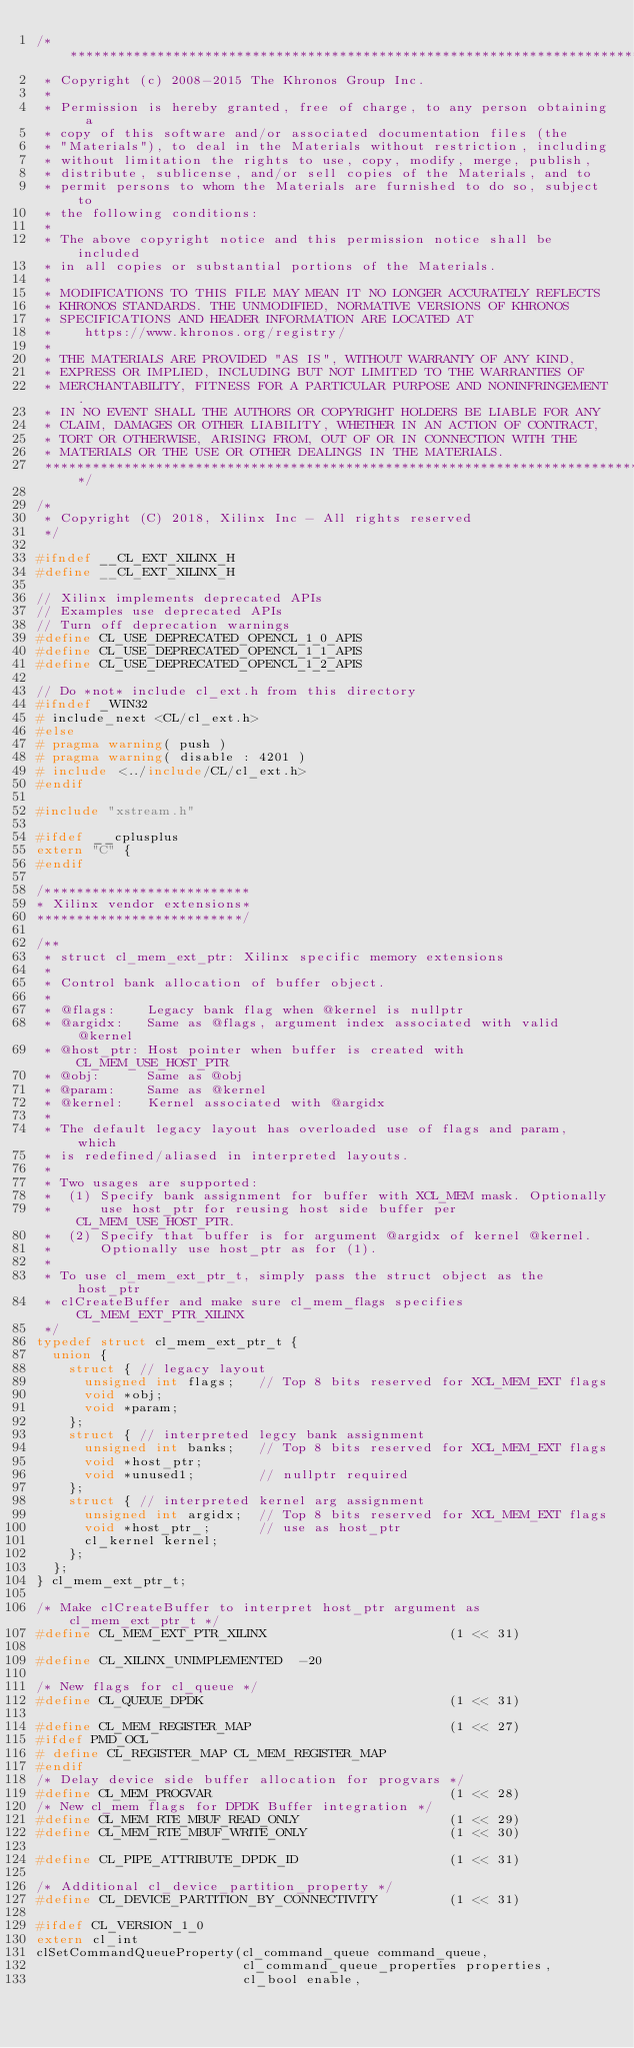Convert code to text. <code><loc_0><loc_0><loc_500><loc_500><_C_>/*******************************************************************************
 * Copyright (c) 2008-2015 The Khronos Group Inc.
 *
 * Permission is hereby granted, free of charge, to any person obtaining a
 * copy of this software and/or associated documentation files (the
 * "Materials"), to deal in the Materials without restriction, including
 * without limitation the rights to use, copy, modify, merge, publish,
 * distribute, sublicense, and/or sell copies of the Materials, and to
 * permit persons to whom the Materials are furnished to do so, subject to
 * the following conditions:
 *
 * The above copyright notice and this permission notice shall be included
 * in all copies or substantial portions of the Materials.
 *
 * MODIFICATIONS TO THIS FILE MAY MEAN IT NO LONGER ACCURATELY REFLECTS
 * KHRONOS STANDARDS. THE UNMODIFIED, NORMATIVE VERSIONS OF KHRONOS
 * SPECIFICATIONS AND HEADER INFORMATION ARE LOCATED AT
 *    https://www.khronos.org/registry/
 *
 * THE MATERIALS ARE PROVIDED "AS IS", WITHOUT WARRANTY OF ANY KIND,
 * EXPRESS OR IMPLIED, INCLUDING BUT NOT LIMITED TO THE WARRANTIES OF
 * MERCHANTABILITY, FITNESS FOR A PARTICULAR PURPOSE AND NONINFRINGEMENT.
 * IN NO EVENT SHALL THE AUTHORS OR COPYRIGHT HOLDERS BE LIABLE FOR ANY
 * CLAIM, DAMAGES OR OTHER LIABILITY, WHETHER IN AN ACTION OF CONTRACT,
 * TORT OR OTHERWISE, ARISING FROM, OUT OF OR IN CONNECTION WITH THE
 * MATERIALS OR THE USE OR OTHER DEALINGS IN THE MATERIALS.
 ******************************************************************************/

/*
 * Copyright (C) 2018, Xilinx Inc - All rights reserved
 */

#ifndef __CL_EXT_XILINX_H
#define __CL_EXT_XILINX_H

// Xilinx implements deprecated APIs
// Examples use deprecated APIs
// Turn off deprecation warnings
#define CL_USE_DEPRECATED_OPENCL_1_0_APIS
#define CL_USE_DEPRECATED_OPENCL_1_1_APIS
#define CL_USE_DEPRECATED_OPENCL_1_2_APIS

// Do *not* include cl_ext.h from this directory
#ifndef _WIN32
# include_next <CL/cl_ext.h>
#else
# pragma warning( push )
# pragma warning( disable : 4201 )
# include <../include/CL/cl_ext.h>
#endif

#include "xstream.h"

#ifdef __cplusplus
extern "C" {
#endif

/**************************
* Xilinx vendor extensions*
**************************/

/**
 * struct cl_mem_ext_ptr: Xilinx specific memory extensions
 *
 * Control bank allocation of buffer object.
 *
 * @flags:    Legacy bank flag when @kernel is nullptr
 * @argidx:   Same as @flags, argument index associated with valid @kernel
 * @host_ptr: Host pointer when buffer is created with CL_MEM_USE_HOST_PTR
 * @obj:      Same as @obj
 * @param:    Same as @kernel
 * @kernel:   Kernel associated with @argidx
 *
 * The default legacy layout has overloaded use of flags and param, which
 * is redefined/aliased in interpreted layouts.
 *
 * Two usages are supported:
 *  (1) Specify bank assignment for buffer with XCL_MEM mask. Optionally
 *      use host_ptr for reusing host side buffer per CL_MEM_USE_HOST_PTR.
 *  (2) Specify that buffer is for argument @argidx of kernel @kernel.
 *      Optionally use host_ptr as for (1).
 *
 * To use cl_mem_ext_ptr_t, simply pass the struct object as the host_ptr
 * clCreateBuffer and make sure cl_mem_flags specifies CL_MEM_EXT_PTR_XILINX
 */
typedef struct cl_mem_ext_ptr_t {
  union {
    struct { // legacy layout
      unsigned int flags;   // Top 8 bits reserved for XCL_MEM_EXT flags
      void *obj;
      void *param;
    };
    struct { // interpreted legcy bank assignment
      unsigned int banks;   // Top 8 bits reserved for XCL_MEM_EXT flags
      void *host_ptr;
      void *unused1;        // nullptr required
    };
    struct { // interpreted kernel arg assignment
      unsigned int argidx;  // Top 8 bits reserved for XCL_MEM_EXT flags
      void *host_ptr_;      // use as host_ptr
      cl_kernel kernel;
    };
  };
} cl_mem_ext_ptr_t;

/* Make clCreateBuffer to interpret host_ptr argument as cl_mem_ext_ptr_t */
#define CL_MEM_EXT_PTR_XILINX                       (1 << 31)

#define CL_XILINX_UNIMPLEMENTED  -20

/* New flags for cl_queue */
#define CL_QUEUE_DPDK                               (1 << 31)

#define CL_MEM_REGISTER_MAP                         (1 << 27)
#ifdef PMD_OCL
# define CL_REGISTER_MAP CL_MEM_REGISTER_MAP
#endif
/* Delay device side buffer allocation for progvars */
#define CL_MEM_PROGVAR                              (1 << 28)
/* New cl_mem flags for DPDK Buffer integration */
#define CL_MEM_RTE_MBUF_READ_ONLY                   (1 << 29)
#define CL_MEM_RTE_MBUF_WRITE_ONLY                  (1 << 30)

#define CL_PIPE_ATTRIBUTE_DPDK_ID                   (1 << 31)

/* Additional cl_device_partition_property */
#define CL_DEVICE_PARTITION_BY_CONNECTIVITY         (1 << 31)

#ifdef CL_VERSION_1_0
extern cl_int
clSetCommandQueueProperty(cl_command_queue command_queue,
                          cl_command_queue_properties properties,
                          cl_bool enable,</code> 